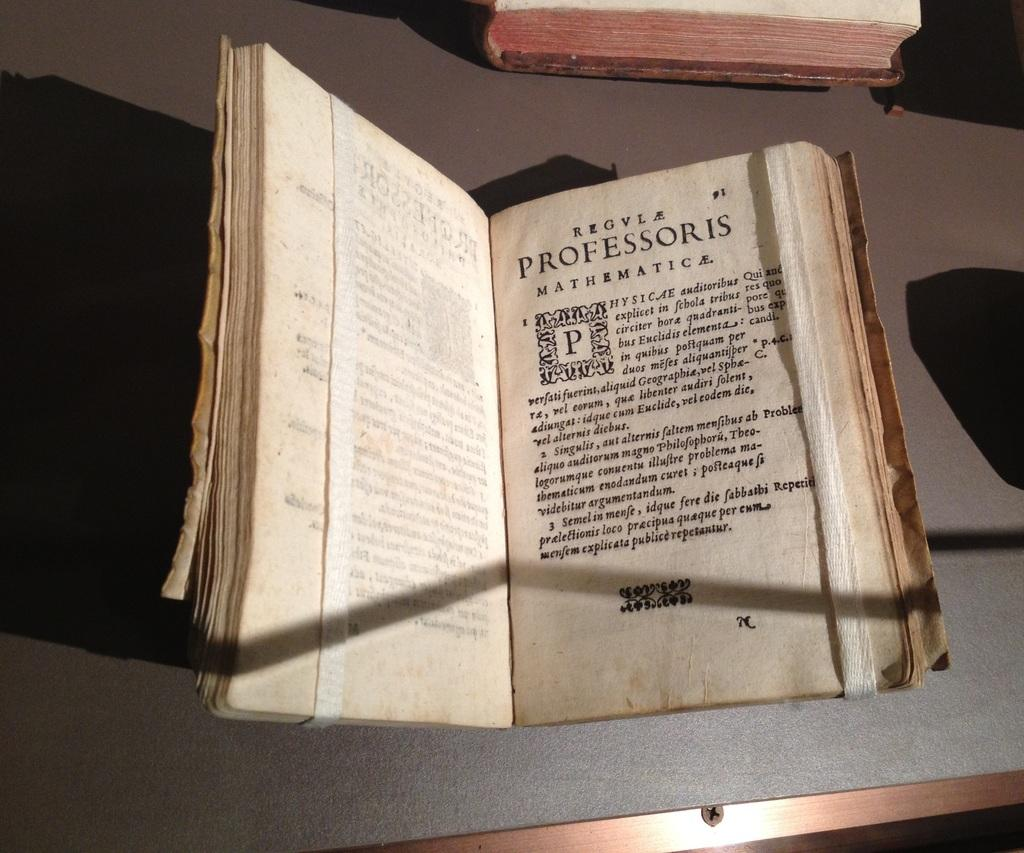<image>
Offer a succinct explanation of the picture presented. An old book with frayed edges is open to page 91 and says Professoris. 